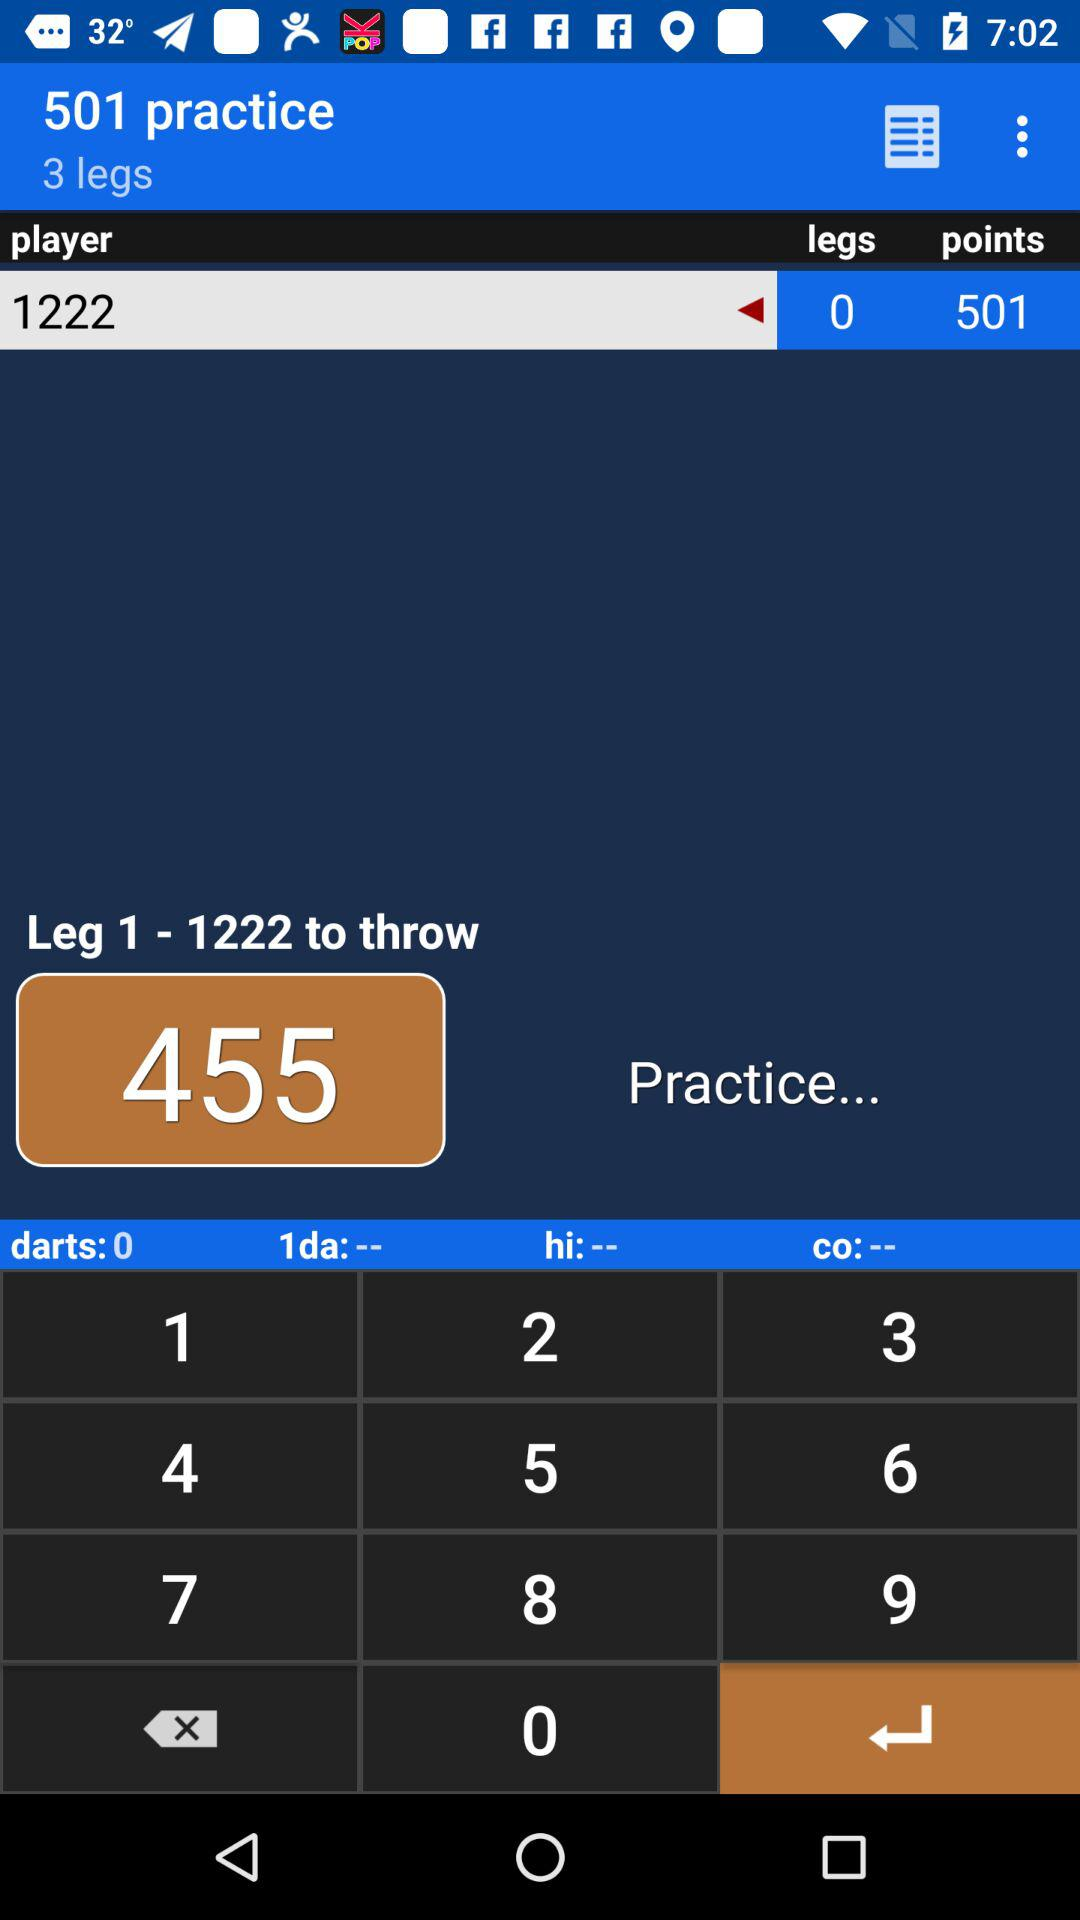How many legs are there?
Answer the question using a single word or phrase. 3 